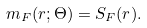<formula> <loc_0><loc_0><loc_500><loc_500>m _ { F } ( r ; \Theta ) = S _ { F } ( r ) .</formula> 